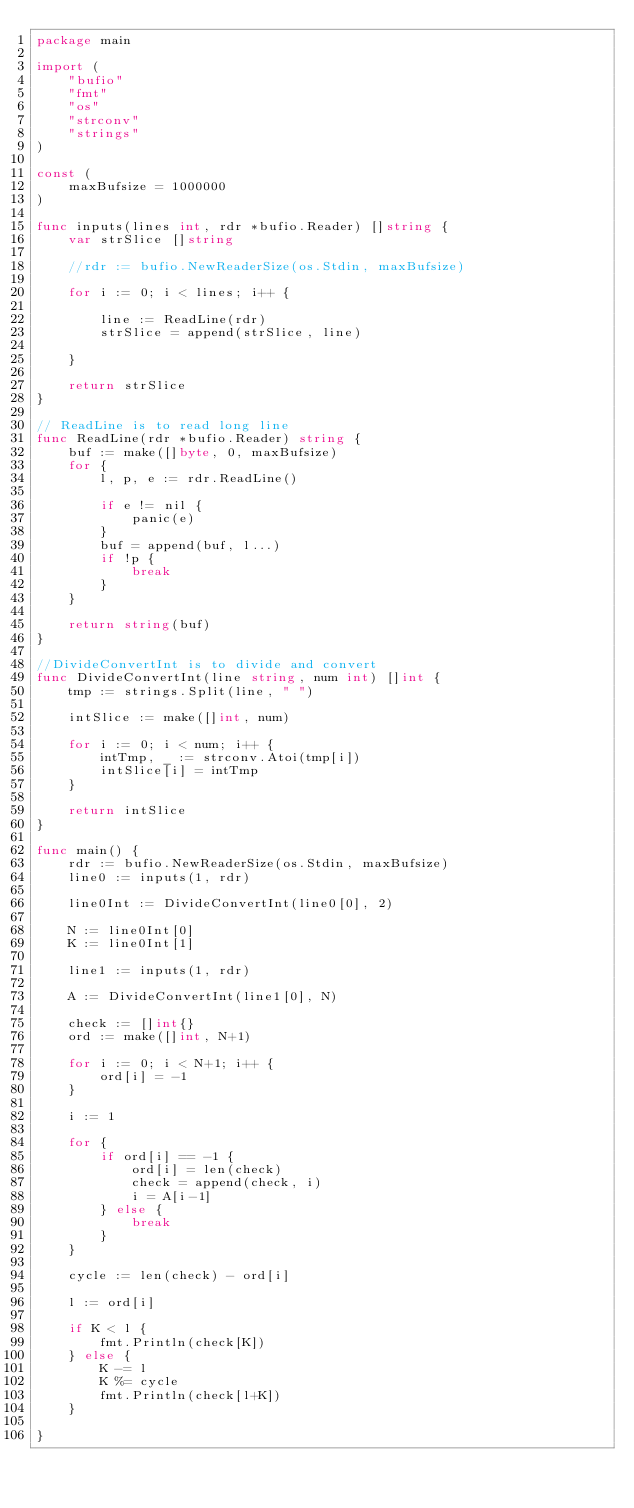<code> <loc_0><loc_0><loc_500><loc_500><_Go_>package main

import (
	"bufio"
	"fmt"
	"os"
	"strconv"
	"strings"
)

const (
	maxBufsize = 1000000
)

func inputs(lines int, rdr *bufio.Reader) []string {
	var strSlice []string

	//rdr := bufio.NewReaderSize(os.Stdin, maxBufsize)

	for i := 0; i < lines; i++ {

		line := ReadLine(rdr)
		strSlice = append(strSlice, line)

	}

	return strSlice
}

// ReadLine is to read long line
func ReadLine(rdr *bufio.Reader) string {
	buf := make([]byte, 0, maxBufsize)
	for {
		l, p, e := rdr.ReadLine()

		if e != nil {
			panic(e)
		}
		buf = append(buf, l...)
		if !p {
			break
		}
	}

	return string(buf)
}

//DivideConvertInt is to divide and convert
func DivideConvertInt(line string, num int) []int {
	tmp := strings.Split(line, " ")

	intSlice := make([]int, num)

	for i := 0; i < num; i++ {
		intTmp, _ := strconv.Atoi(tmp[i])
		intSlice[i] = intTmp
	}

	return intSlice
}

func main() {
	rdr := bufio.NewReaderSize(os.Stdin, maxBufsize)
	line0 := inputs(1, rdr)

	line0Int := DivideConvertInt(line0[0], 2)

	N := line0Int[0]
	K := line0Int[1]

	line1 := inputs(1, rdr)

	A := DivideConvertInt(line1[0], N)

	check := []int{}
	ord := make([]int, N+1)

	for i := 0; i < N+1; i++ {
		ord[i] = -1
	}

	i := 1

	for {
		if ord[i] == -1 {
			ord[i] = len(check)
			check = append(check, i)
			i = A[i-1]
		} else {
			break
		}
	}

	cycle := len(check) - ord[i]

	l := ord[i]

	if K < l {
		fmt.Println(check[K])
	} else {
		K -= l
		K %= cycle
		fmt.Println(check[l+K])
	}

}
</code> 